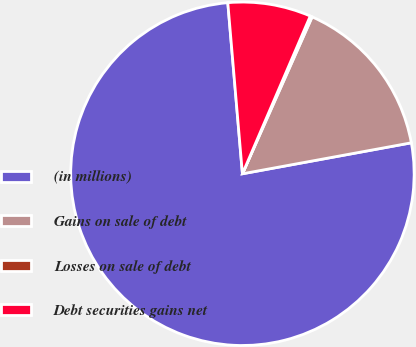Convert chart to OTSL. <chart><loc_0><loc_0><loc_500><loc_500><pie_chart><fcel>(in millions)<fcel>Gains on sale of debt<fcel>Losses on sale of debt<fcel>Debt securities gains net<nl><fcel>76.53%<fcel>15.46%<fcel>0.19%<fcel>7.82%<nl></chart> 